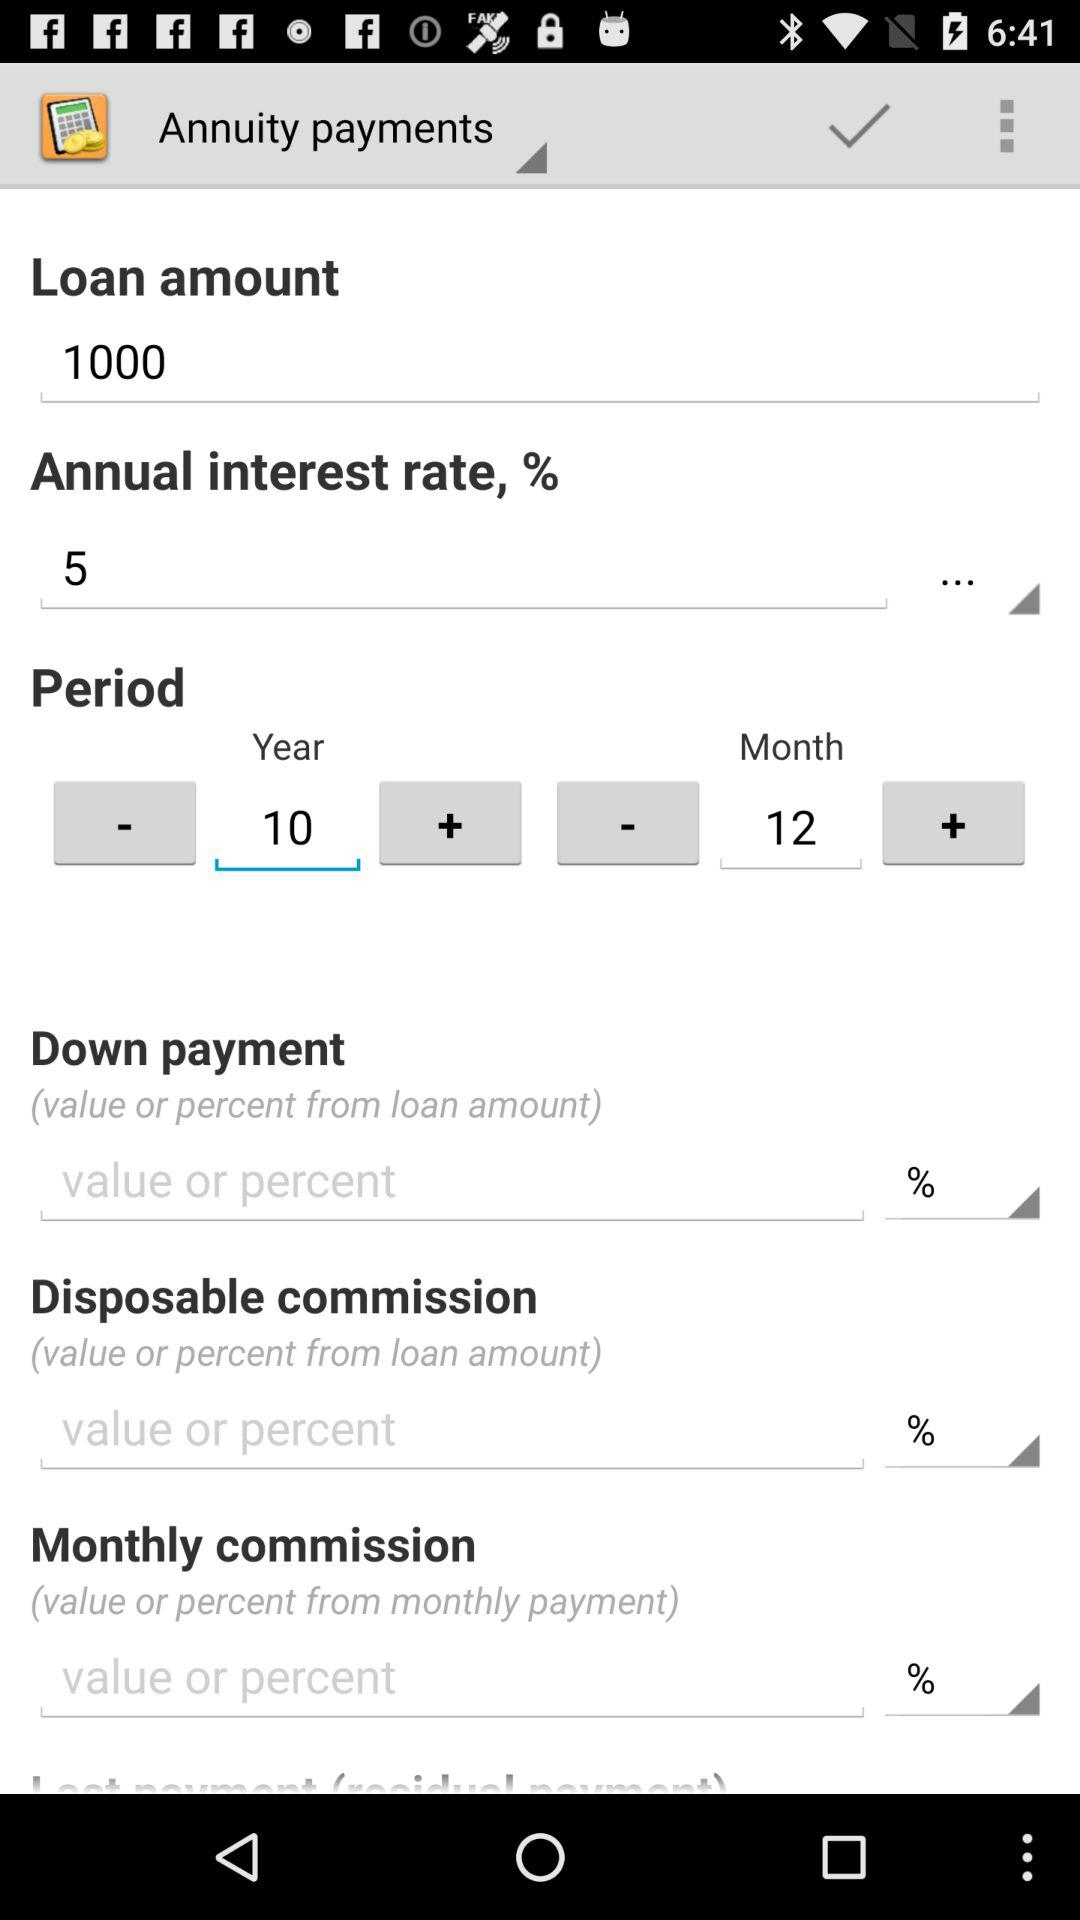What is the annual rate of interest? The annual rate of interest is 5%. 